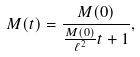<formula> <loc_0><loc_0><loc_500><loc_500>M ( t ) = \frac { M ( 0 ) } { \frac { M ( 0 ) } { \ell ^ { 2 } } t + 1 } ,</formula> 